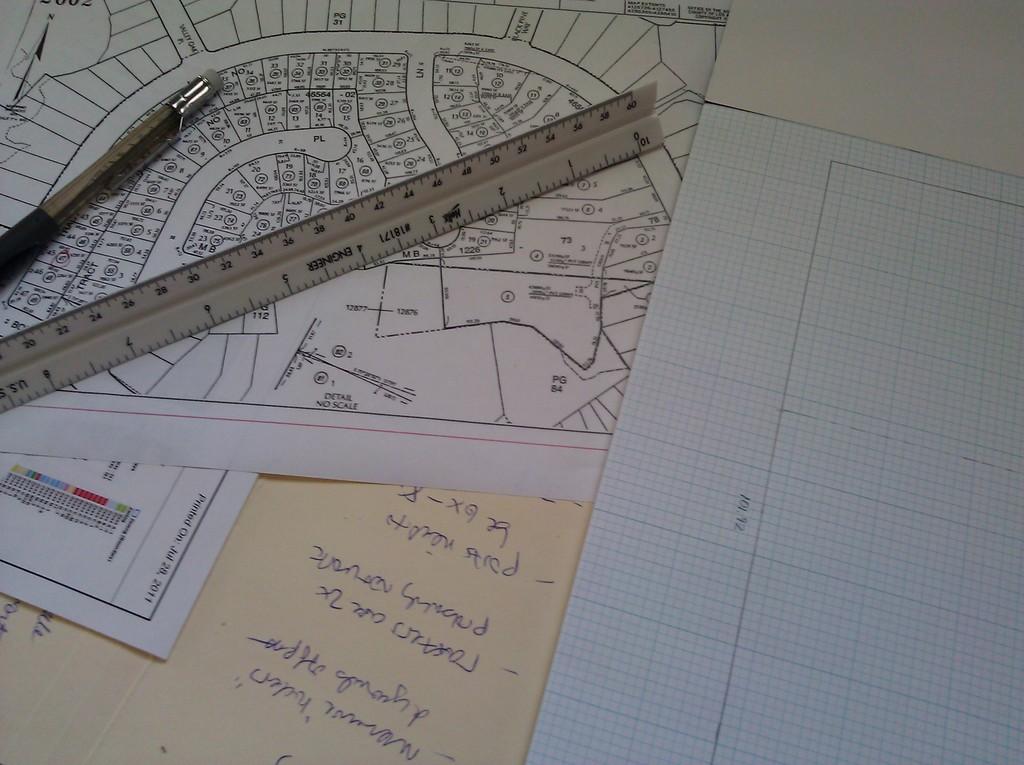What year is on the blueprint?
Your answer should be compact. Unanswerable. 